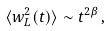<formula> <loc_0><loc_0><loc_500><loc_500>\langle w _ { L } ^ { 2 } ( t ) \rangle \sim t ^ { 2 \beta } \, ,</formula> 